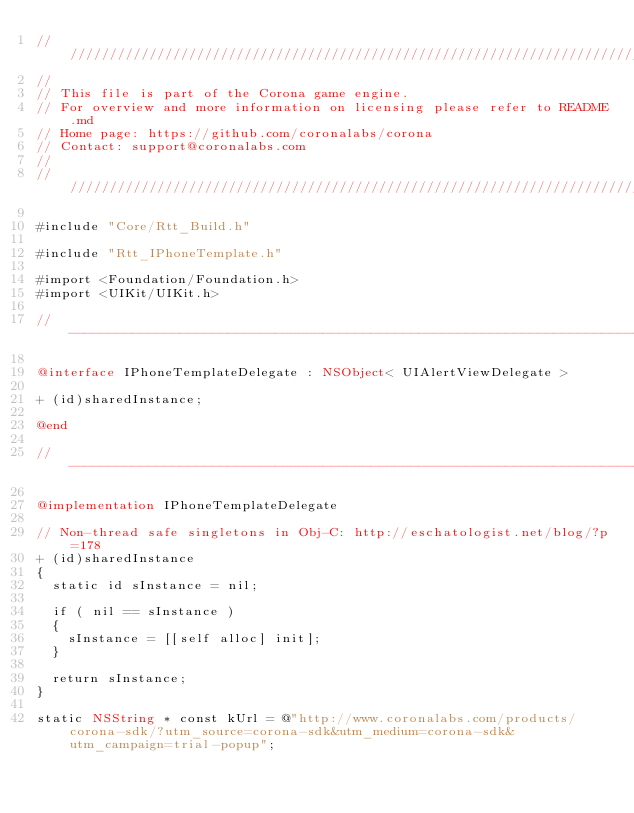<code> <loc_0><loc_0><loc_500><loc_500><_ObjectiveC_>//////////////////////////////////////////////////////////////////////////////
//
// This file is part of the Corona game engine.
// For overview and more information on licensing please refer to README.md 
// Home page: https://github.com/coronalabs/corona
// Contact: support@coronalabs.com
//
//////////////////////////////////////////////////////////////////////////////

#include "Core/Rtt_Build.h"

#include "Rtt_IPhoneTemplate.h"

#import <Foundation/Foundation.h>
#import <UIKit/UIKit.h>

// ----------------------------------------------------------------------------

@interface IPhoneTemplateDelegate : NSObject< UIAlertViewDelegate >

+ (id)sharedInstance;

@end

// ----------------------------------------------------------------------------

@implementation IPhoneTemplateDelegate

// Non-thread safe singletons in Obj-C: http://eschatologist.net/blog/?p=178
+ (id)sharedInstance
{
	static id sInstance = nil;

	if ( nil == sInstance )
	{
		sInstance = [[self alloc] init];
	}

	return sInstance;
}

static NSString * const kUrl = @"http://www.coronalabs.com/products/corona-sdk/?utm_source=corona-sdk&utm_medium=corona-sdk&utm_campaign=trial-popup";
</code> 